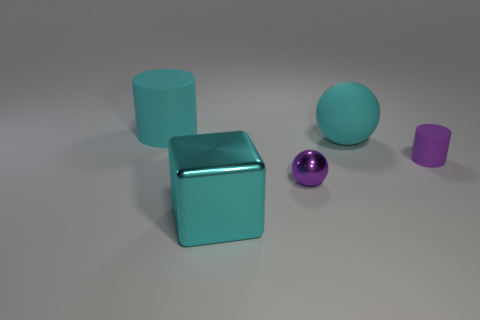What material is the small purple object in front of the small object that is behind the tiny purple shiny ball? While the image doesn't provide explicit information about the material composition of objects, the small purple object in front of the cube behind the shiny purple ball appears to have a matte finish, which could suggest it is made of plastic or a painted metal, less reflective than the shiny ball. 